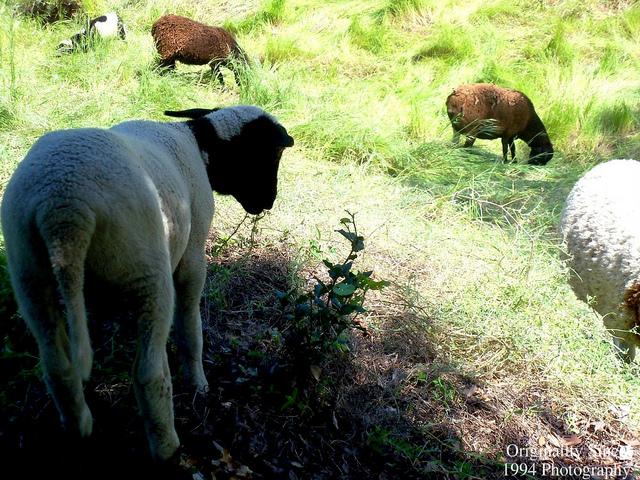Are all of the sheep white?
Write a very short answer. No. Is the sheep enclosed?
Be succinct. No. What kind of plant is the lamb eating?
Give a very brief answer. Grass. Is this type of sheep mentioned in a children's song?
Write a very short answer. Yes. How many lambs are there?
Keep it brief. 4. Is the sheep making a sound?
Give a very brief answer. No. How many animals are in the picture?
Write a very short answer. 5. 